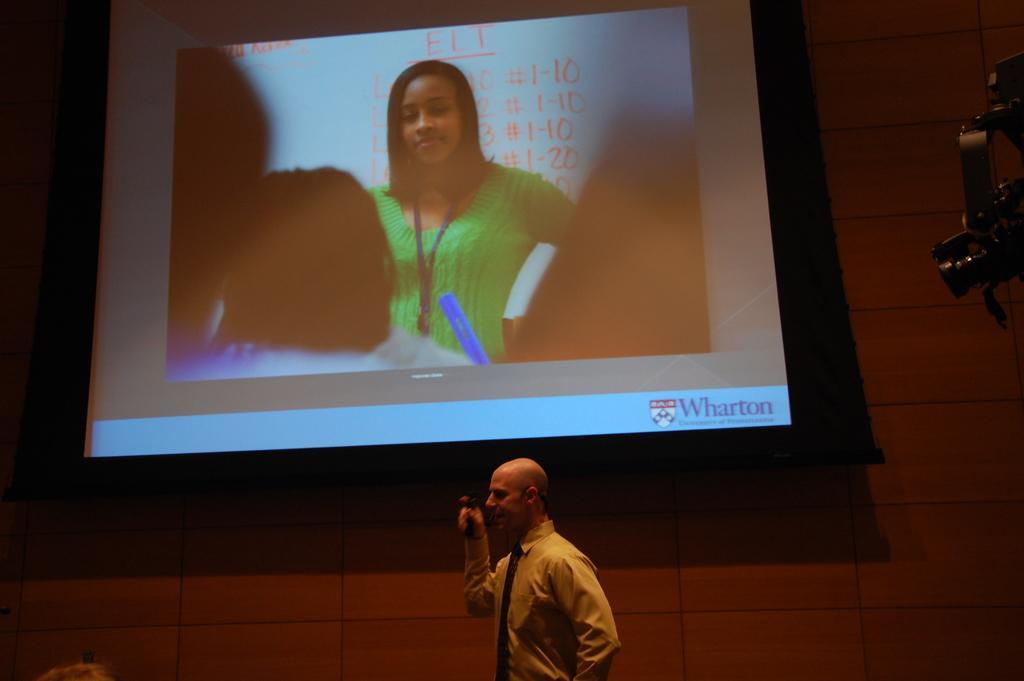Please provide a concise description of this image. At the bottom of the image we can see a man standing and talking. On the right there is a camera. In the center we can see a screen. In the background there is a wall. 